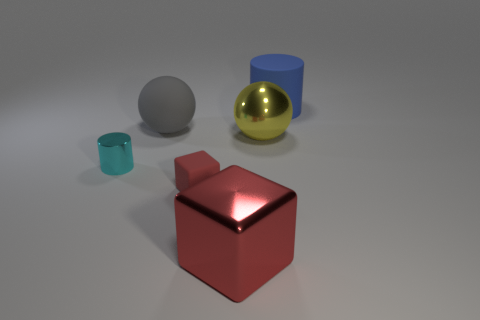Subtract all yellow spheres. How many spheres are left? 1 Subtract all cubes. How many objects are left? 4 Subtract all cyan spheres. How many purple cylinders are left? 0 Add 4 metallic spheres. How many objects exist? 10 Subtract 0 cyan cubes. How many objects are left? 6 Subtract 2 blocks. How many blocks are left? 0 Subtract all blue blocks. Subtract all red spheres. How many blocks are left? 2 Subtract all yellow balls. Subtract all yellow shiny spheres. How many objects are left? 4 Add 4 big red metal things. How many big red metal things are left? 5 Add 6 big cylinders. How many big cylinders exist? 7 